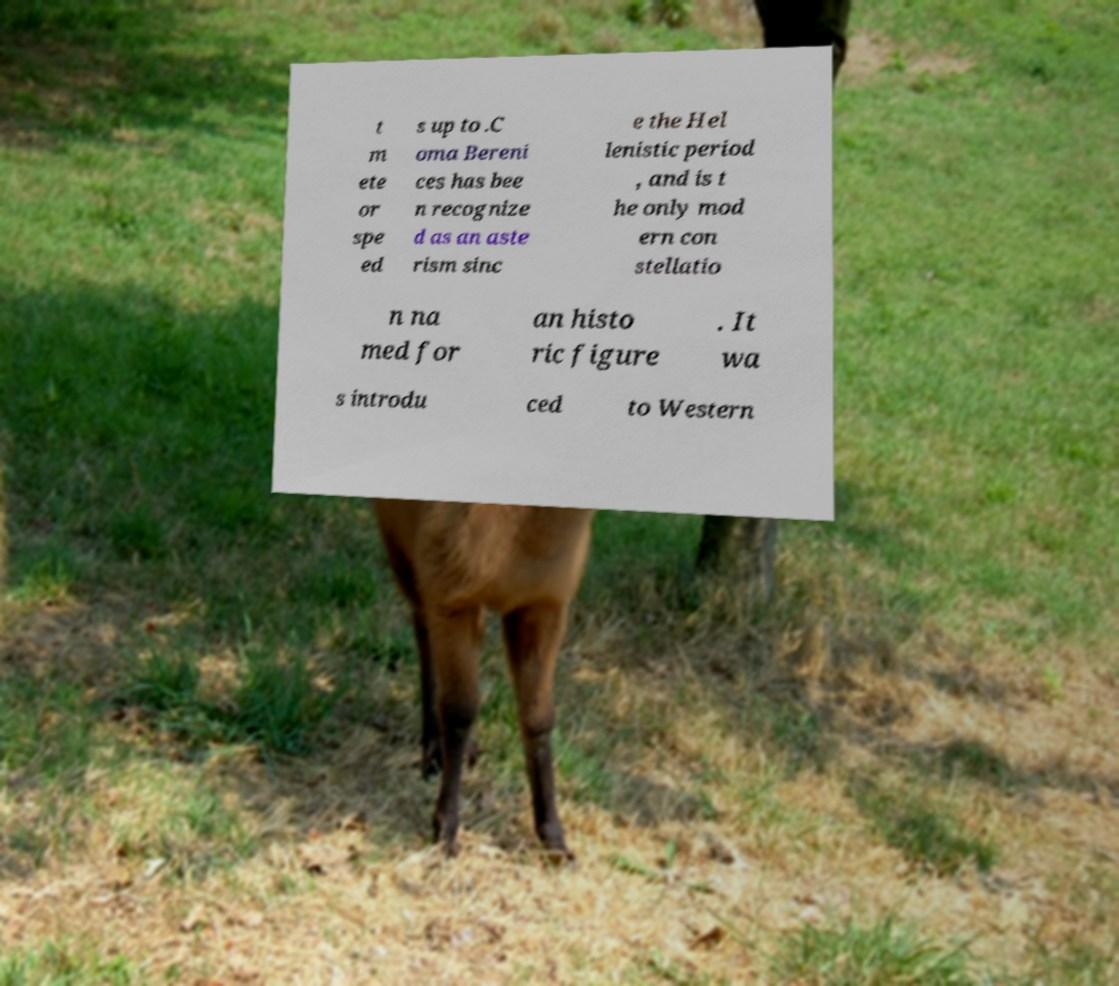Can you read and provide the text displayed in the image?This photo seems to have some interesting text. Can you extract and type it out for me? t m ete or spe ed s up to .C oma Bereni ces has bee n recognize d as an aste rism sinc e the Hel lenistic period , and is t he only mod ern con stellatio n na med for an histo ric figure . It wa s introdu ced to Western 